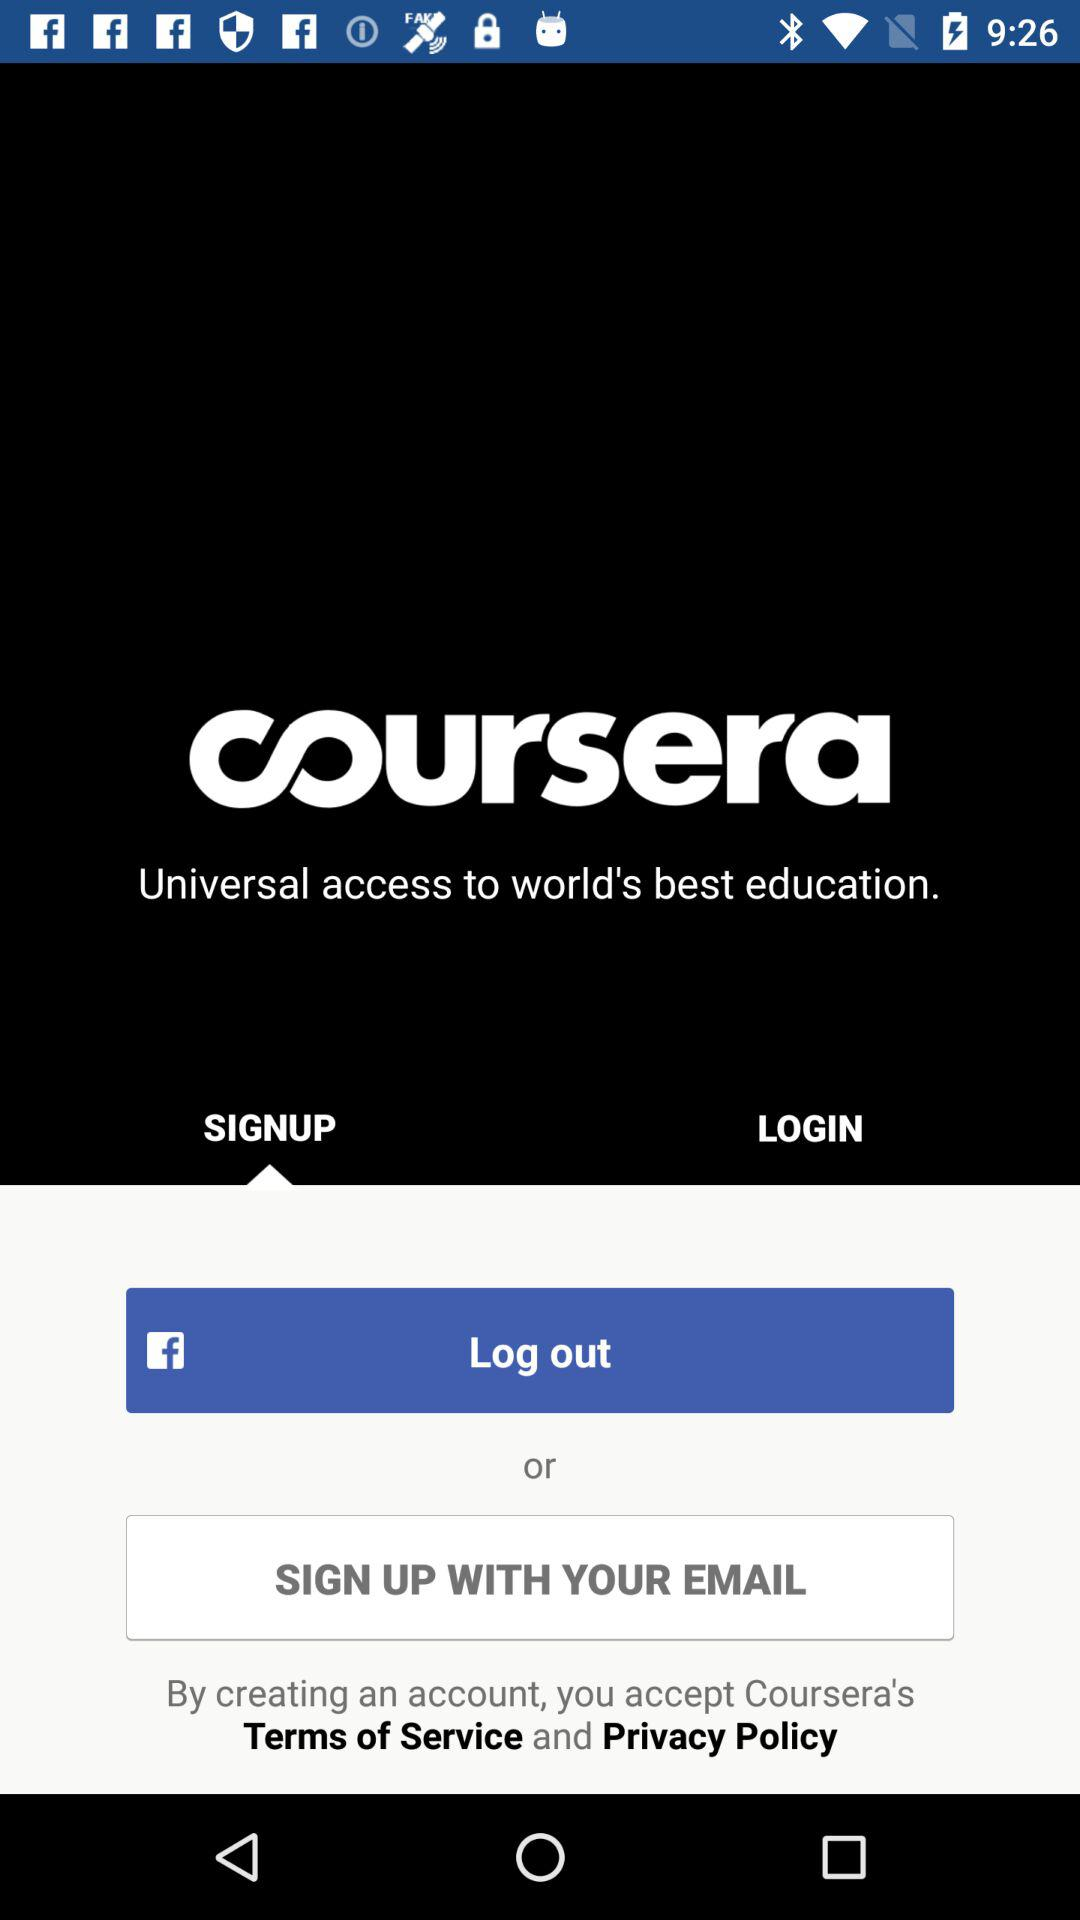Through what application can we sign up? You can sign up through "Facebook". 